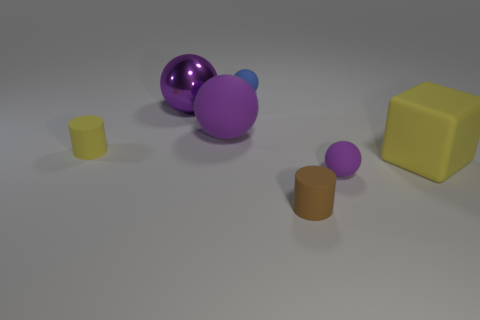Subtract all green cylinders. How many purple spheres are left? 3 Add 3 tiny yellow rubber balls. How many objects exist? 10 Subtract 1 spheres. How many spheres are left? 3 Subtract all shiny spheres. How many spheres are left? 3 Subtract all blue balls. How many balls are left? 3 Subtract all spheres. How many objects are left? 3 Subtract all yellow balls. Subtract all green cylinders. How many balls are left? 4 Subtract all large yellow rubber cubes. Subtract all yellow cylinders. How many objects are left? 5 Add 2 tiny rubber cylinders. How many tiny rubber cylinders are left? 4 Add 6 metallic objects. How many metallic objects exist? 7 